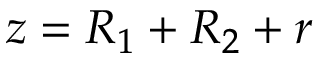Convert formula to latex. <formula><loc_0><loc_0><loc_500><loc_500>\ z = R _ { 1 } + R _ { 2 } + r</formula> 